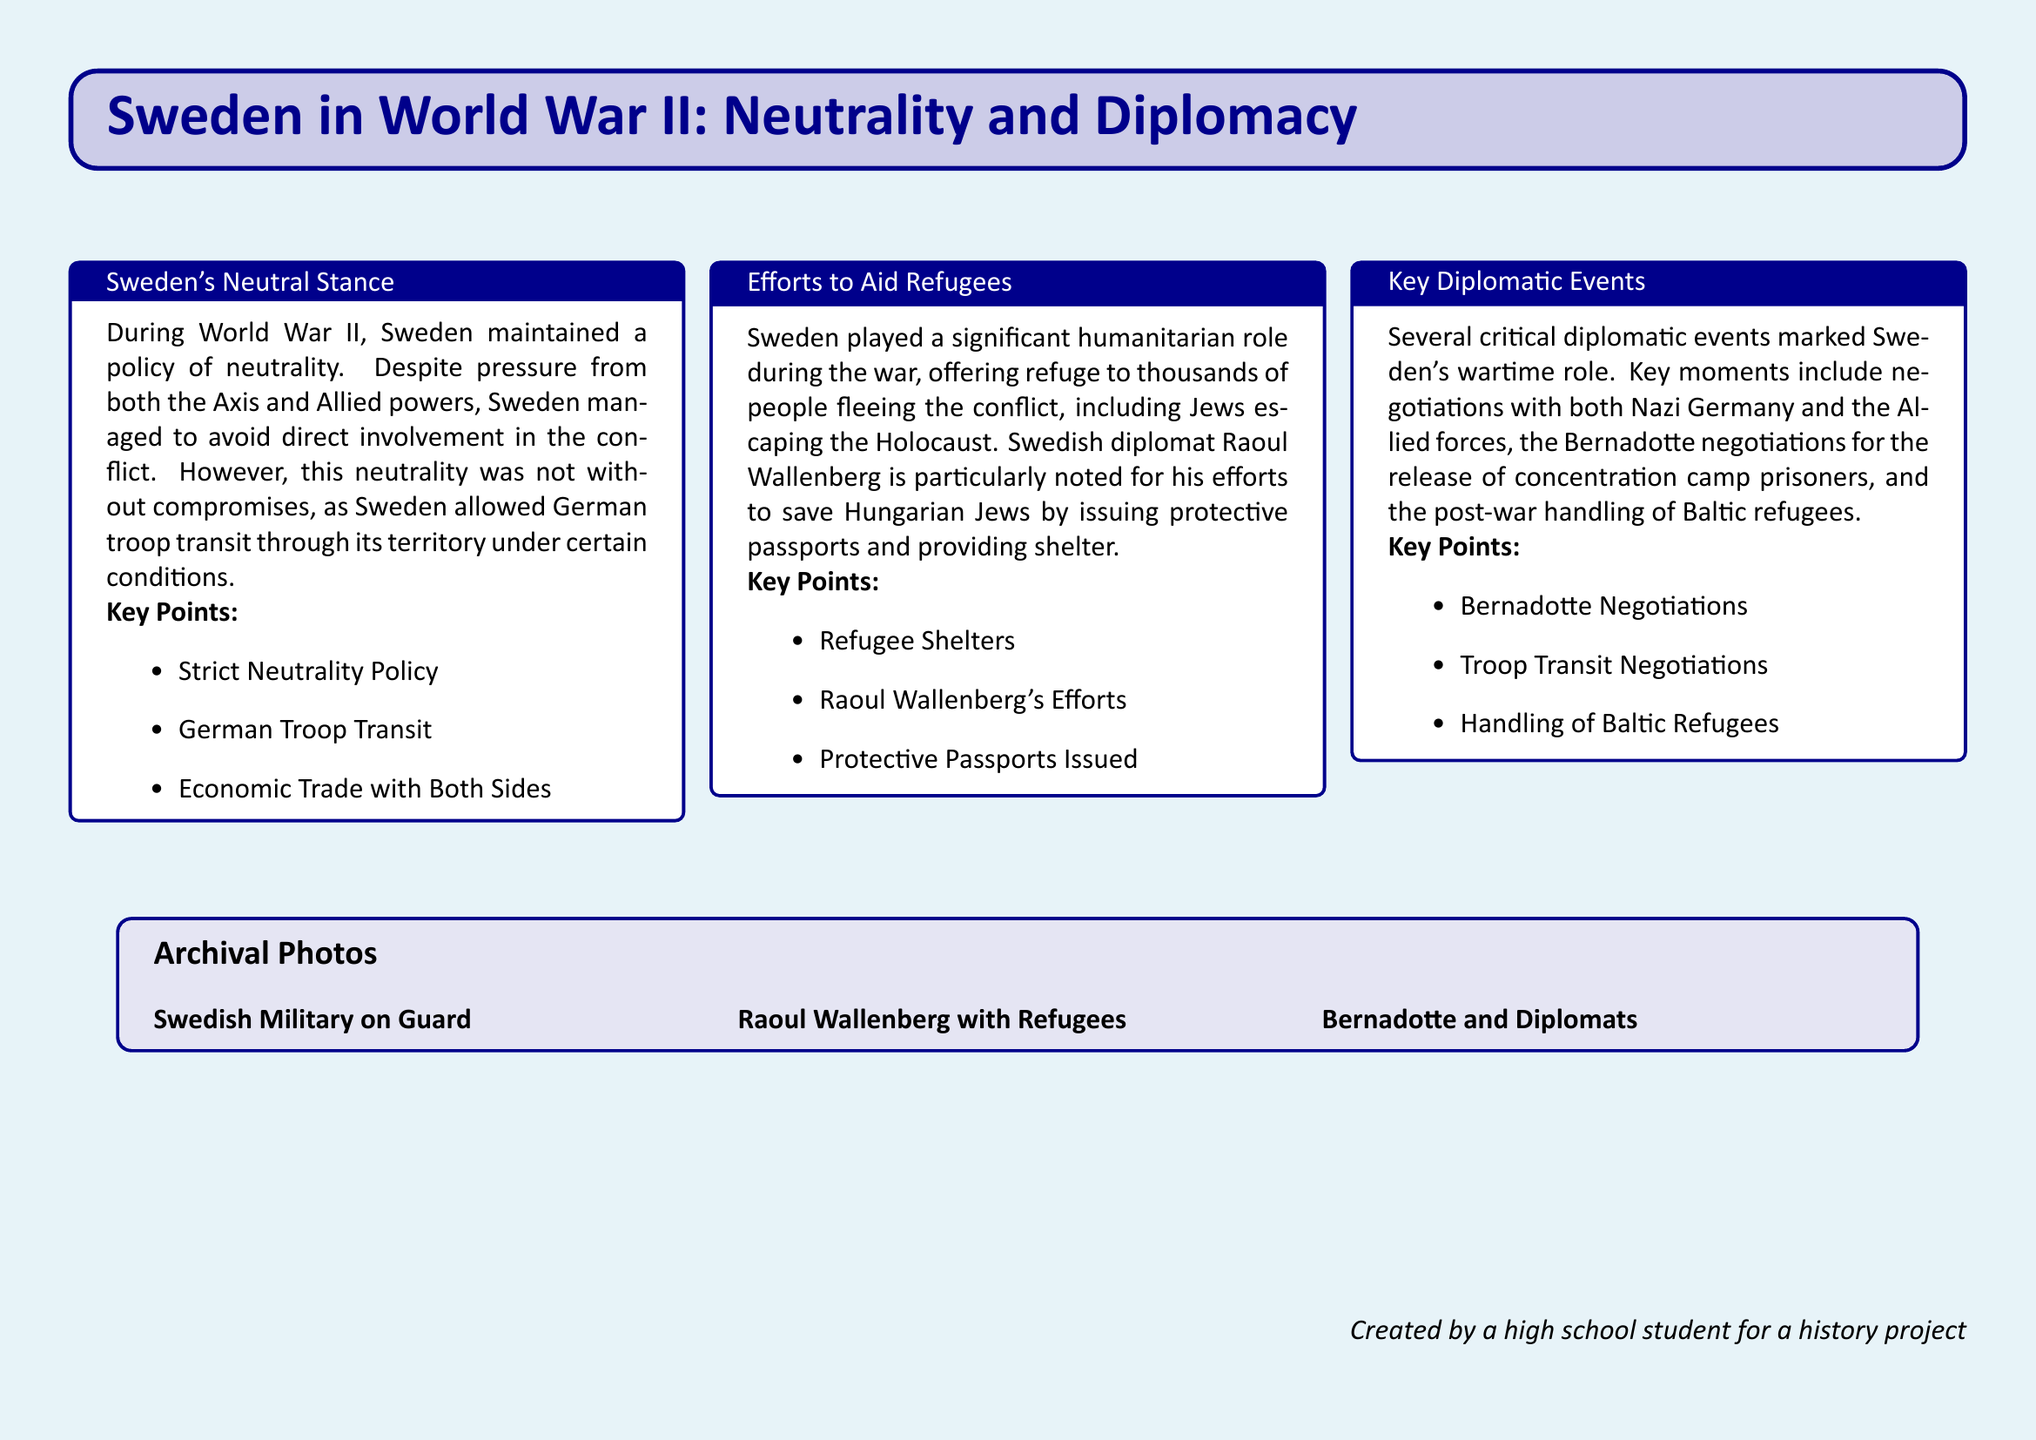What was Sweden's policy during World War II? The document mentions that Sweden maintained a strict neutrality policy during World War II.
Answer: Neutrality Who is noted for efforts to save Hungarian Jews? The document highlights Raoul Wallenberg for his significant humanitarian efforts during the war.
Answer: Raoul Wallenberg What type of passports did Wallenberg provide? The document states that protective passports were issued by Raoul Wallenberg to aid refugees.
Answer: Protective Passports What were the Bernadotte negotiations about? The document refers to the Bernadotte negotiations related to the release of concentration camp prisoners.
Answer: Release of prisoners How many people did Sweden offer refuge to? The document states that Sweden offered refuge to thousands of people fleeing the conflict.
Answer: Thousands What was allowed concerning German troop transit? The document mentions that Sweden allowed German troop transit through its territory under certain conditions.
Answer: German Troop Transit What role did Sweden play in aiding refugees? The document indicates that Sweden played a significant humanitarian role during the war by offering shelters.
Answer: Refugee Shelters What was a key diplomatic event involving Nazi Germany? The document refers to troop transit negotiations as a key diplomatic event with Nazi Germany.
Answer: Troop Transit Negotiations 